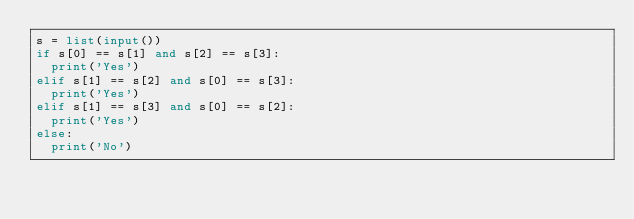<code> <loc_0><loc_0><loc_500><loc_500><_Python_>s = list(input())
if s[0] == s[1] and s[2] == s[3]:
  print('Yes')
elif s[1] == s[2] and s[0] == s[3]:
  print('Yes')
elif s[1] == s[3] and s[0] == s[2]:
  print('Yes')
else:
  print('No')</code> 